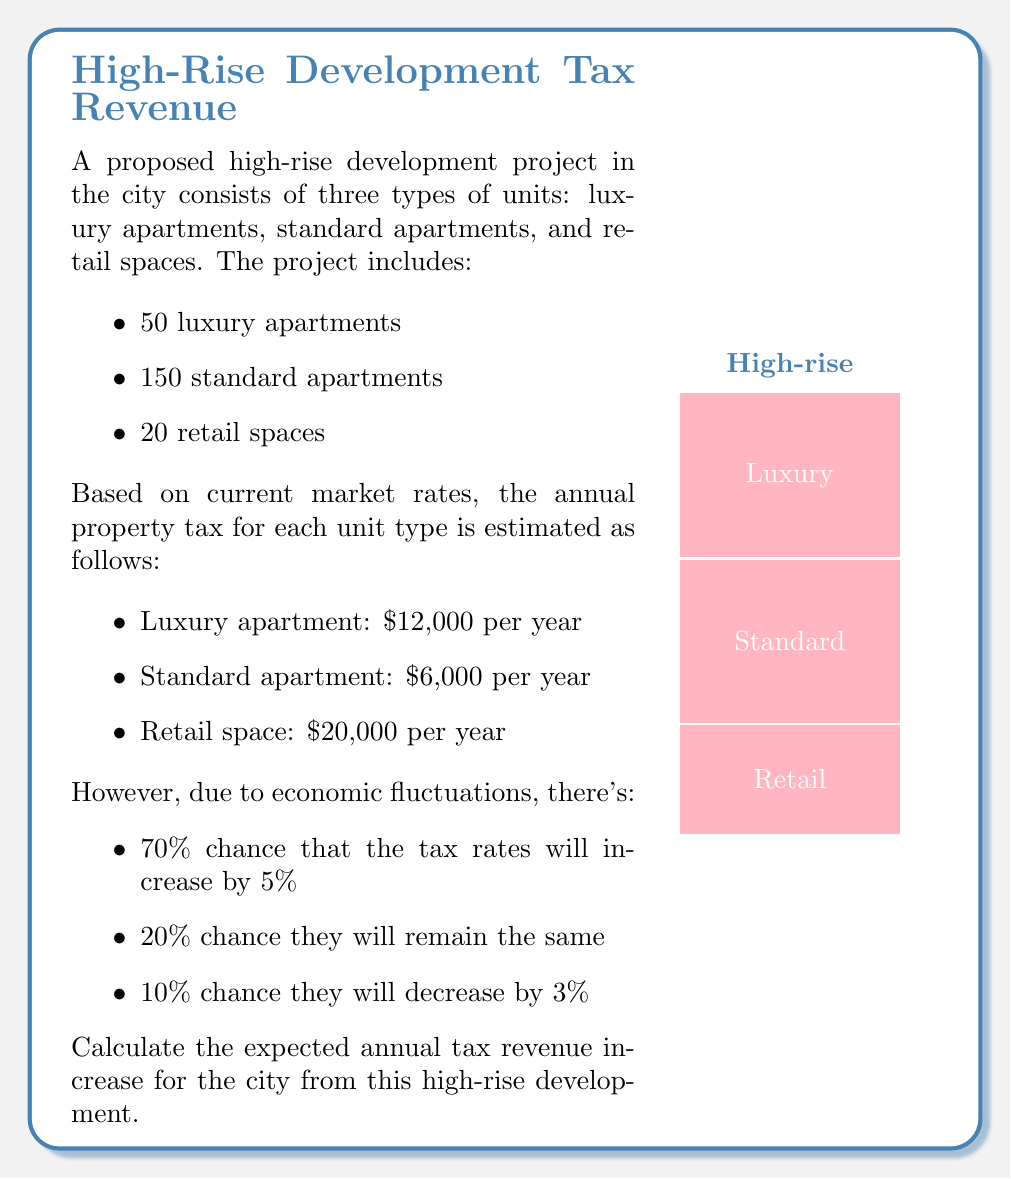Provide a solution to this math problem. Let's approach this problem step-by-step:

1) First, calculate the base annual tax revenue:
   
   Luxury apartments: $50 \times \$12,000 = \$600,000$
   Standard apartments: $150 \times \$6,000 = \$900,000$
   Retail spaces: $20 \times \$20,000 = \$400,000$
   
   Total base revenue: $\$600,000 + \$900,000 + \$400,000 = \$1,900,000$

2) Now, let's calculate the revenue for each scenario:

   a) 5% increase (70% probability):
      $\$1,900,000 \times 1.05 = \$1,995,000$
   
   b) No change (20% probability):
      $\$1,900,000$
   
   c) 3% decrease (10% probability):
      $\$1,900,000 \times 0.97 = \$1,843,000$

3) Calculate the expected value using the probability of each scenario:

   $E(\text{Revenue}) = (0.70 \times \$1,995,000) + (0.20 \times \$1,900,000) + (0.10 \times \$1,843,000)$

4) Simplify:
   
   $E(\text{Revenue}) = \$1,396,500 + \$380,000 + \$184,300 = \$1,960,800$

5) The expected annual tax revenue increase is the difference between the expected revenue and the base revenue:

   $\$1,960,800 - \$1,900,000 = \$60,800$

Therefore, the expected annual tax revenue increase for the city from this high-rise development is $\$60,800$.
Answer: $\$60,800$ 